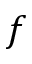Convert formula to latex. <formula><loc_0><loc_0><loc_500><loc_500>f</formula> 